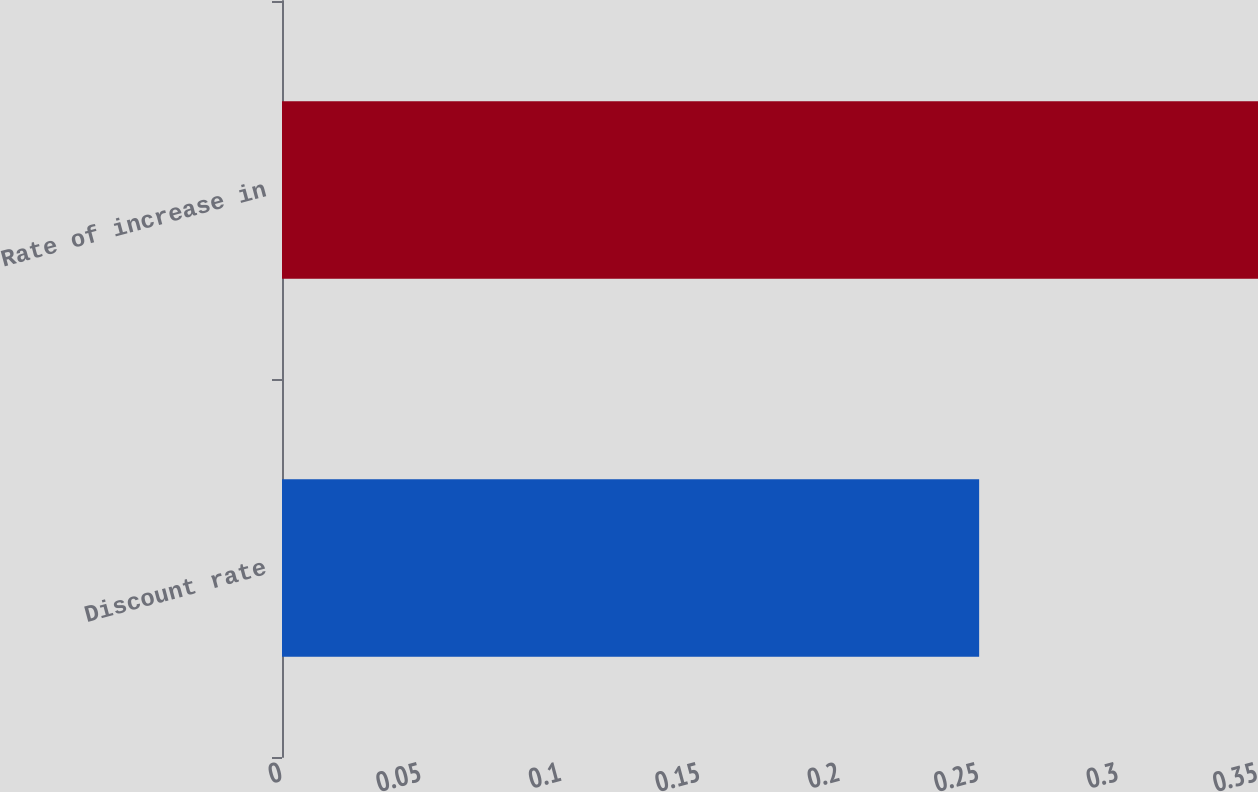<chart> <loc_0><loc_0><loc_500><loc_500><bar_chart><fcel>Discount rate<fcel>Rate of increase in<nl><fcel>0.25<fcel>0.35<nl></chart> 